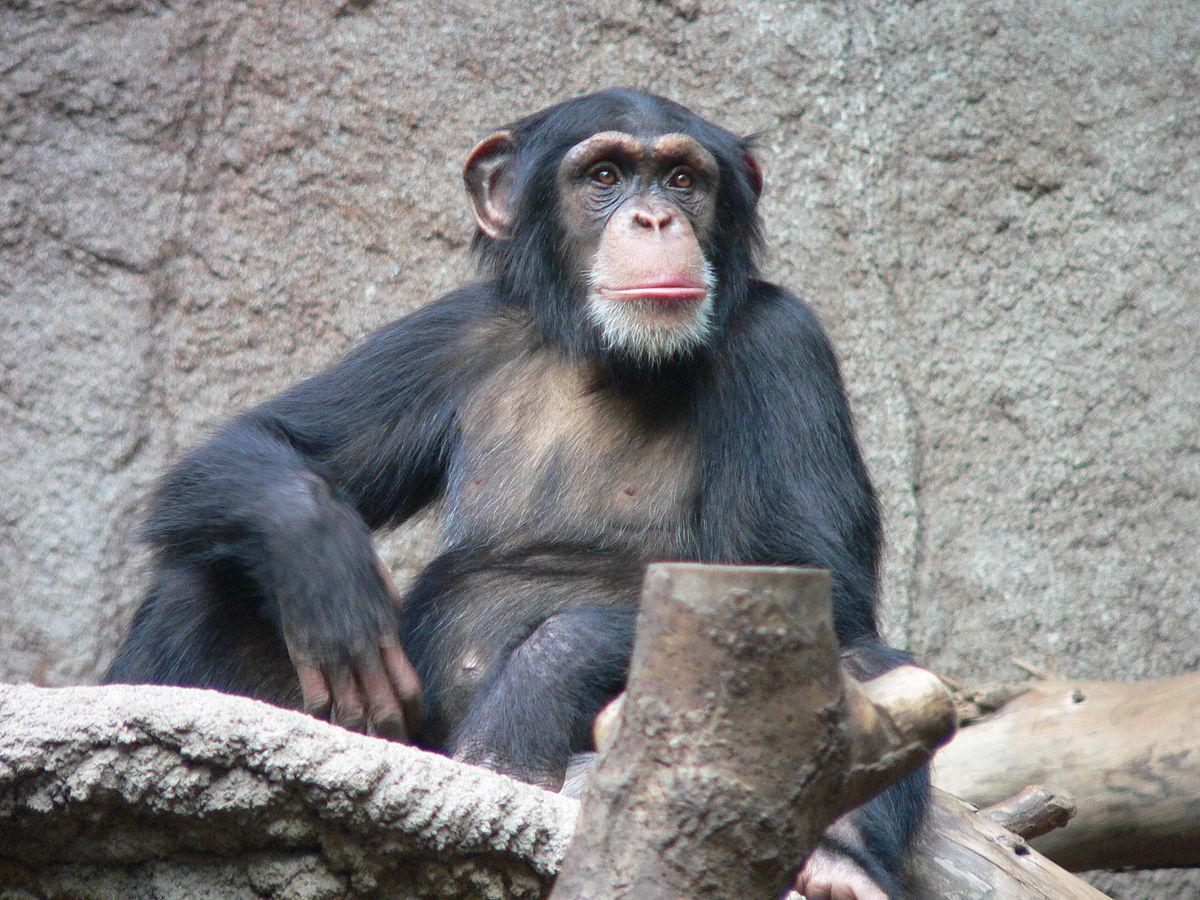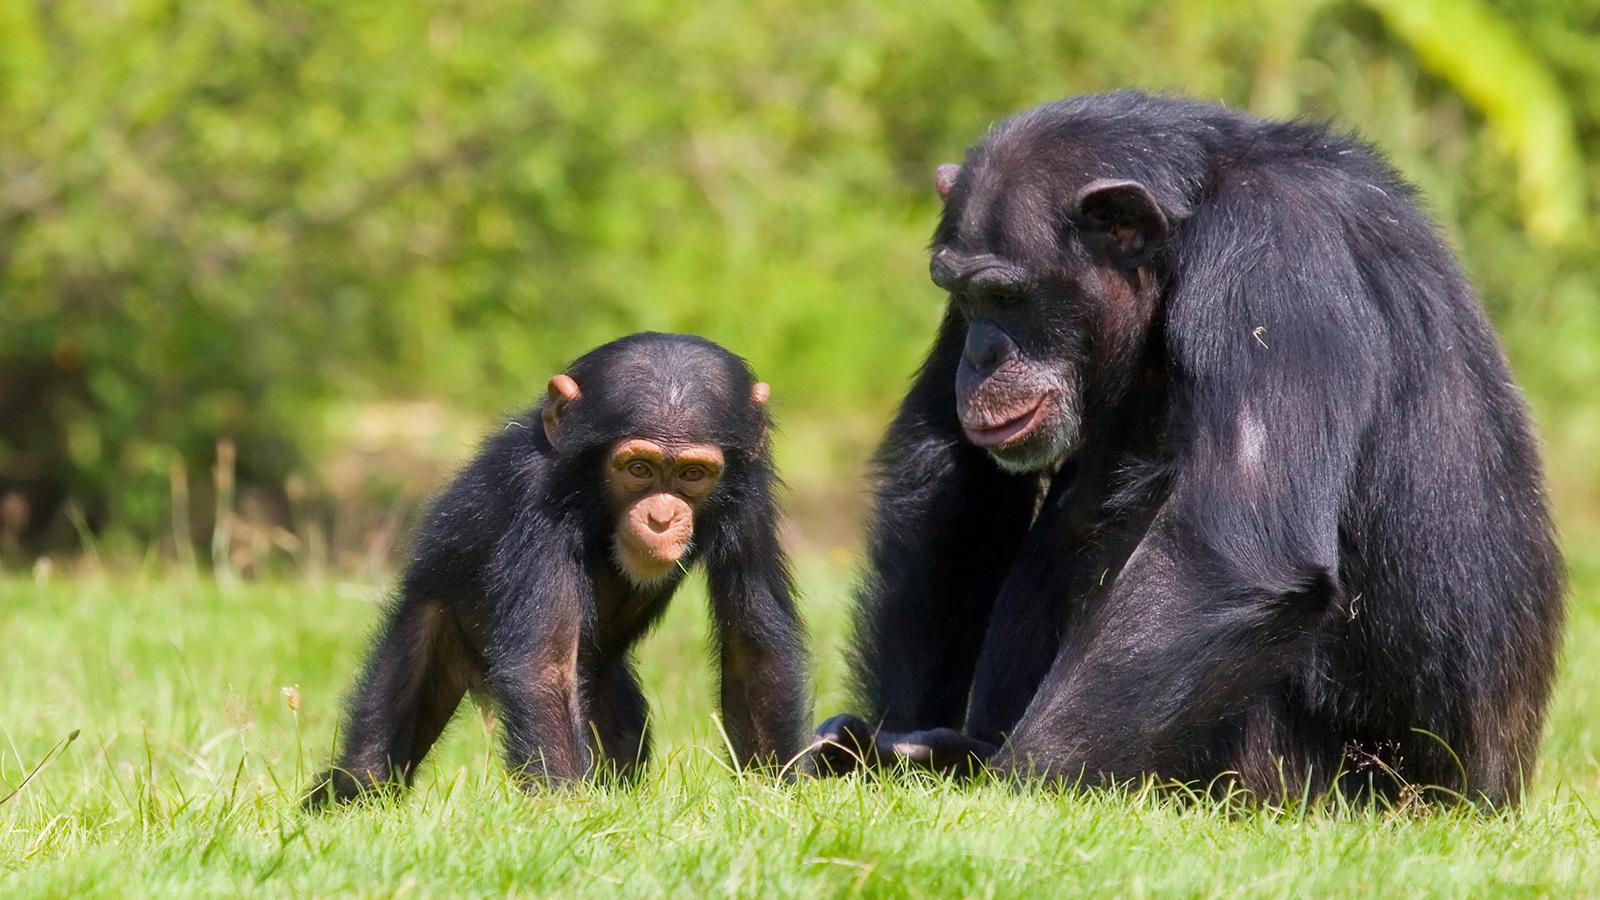The first image is the image on the left, the second image is the image on the right. Examine the images to the left and right. Is the description "Two chimps of the same approximate size and age are present in the right image." accurate? Answer yes or no. No. The first image is the image on the left, the second image is the image on the right. For the images shown, is this caption "There is exactly one monkey in the image on the left." true? Answer yes or no. Yes. 